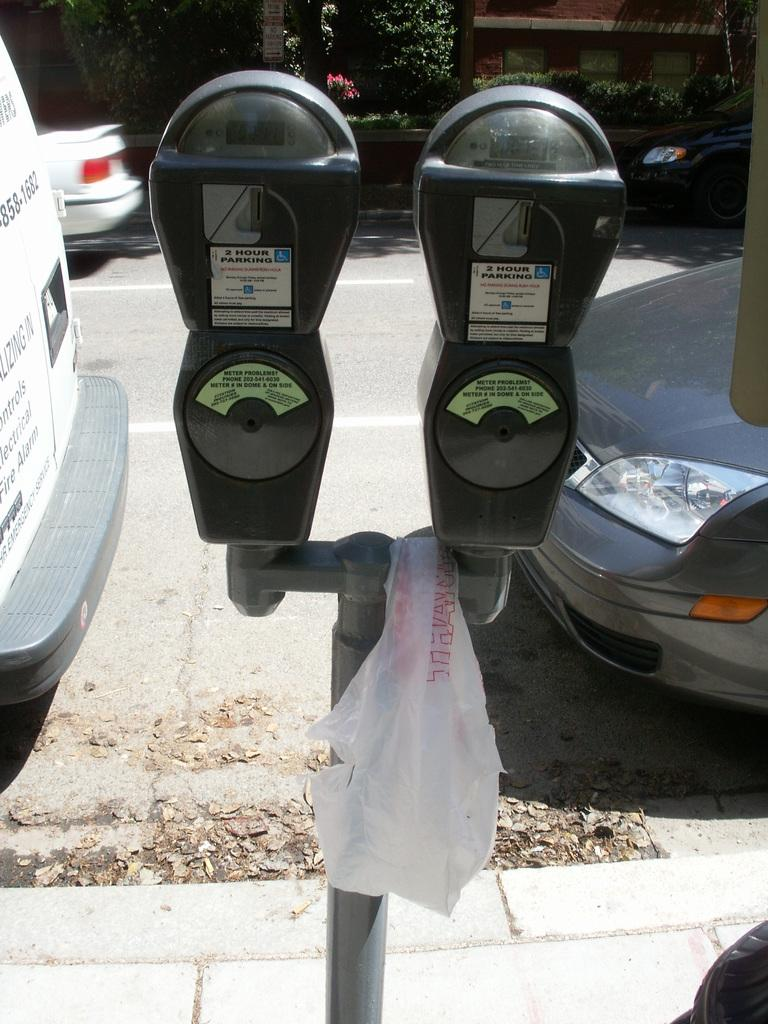<image>
Create a compact narrative representing the image presented. A dual set of parking meters that read 2 hour parking. 